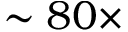Convert formula to latex. <formula><loc_0><loc_0><loc_500><loc_500>\sim 8 0 \times</formula> 